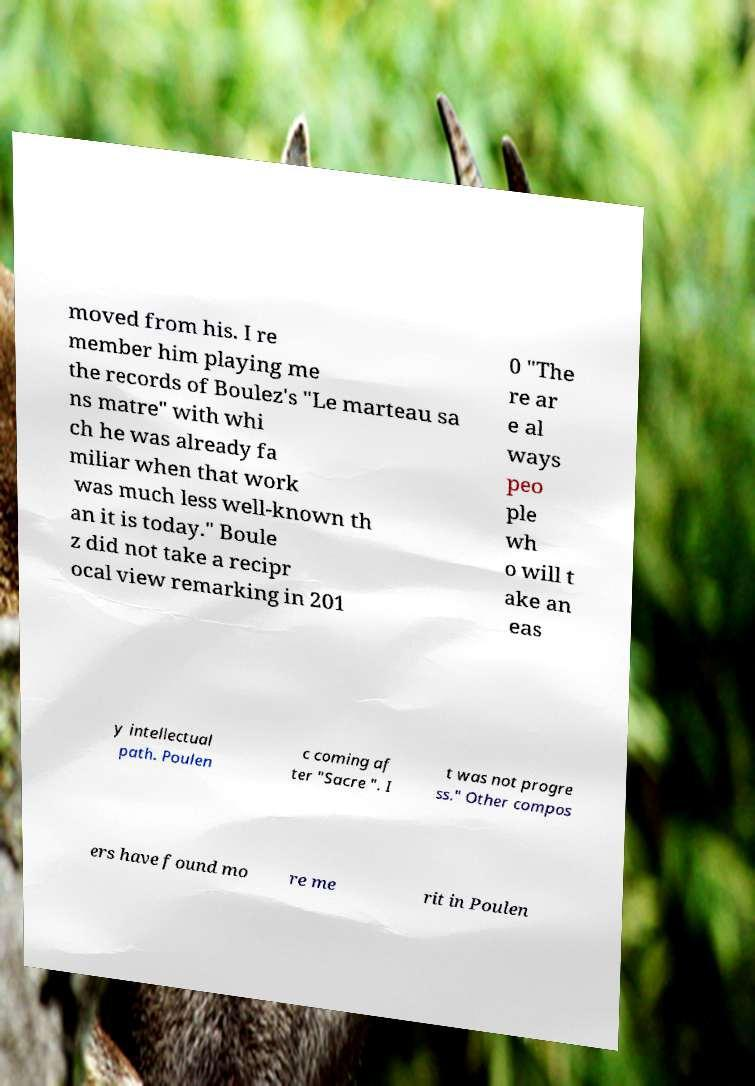There's text embedded in this image that I need extracted. Can you transcribe it verbatim? moved from his. I re member him playing me the records of Boulez's "Le marteau sa ns matre" with whi ch he was already fa miliar when that work was much less well-known th an it is today." Boule z did not take a recipr ocal view remarking in 201 0 "The re ar e al ways peo ple wh o will t ake an eas y intellectual path. Poulen c coming af ter "Sacre ". I t was not progre ss." Other compos ers have found mo re me rit in Poulen 